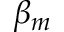Convert formula to latex. <formula><loc_0><loc_0><loc_500><loc_500>\beta _ { m }</formula> 